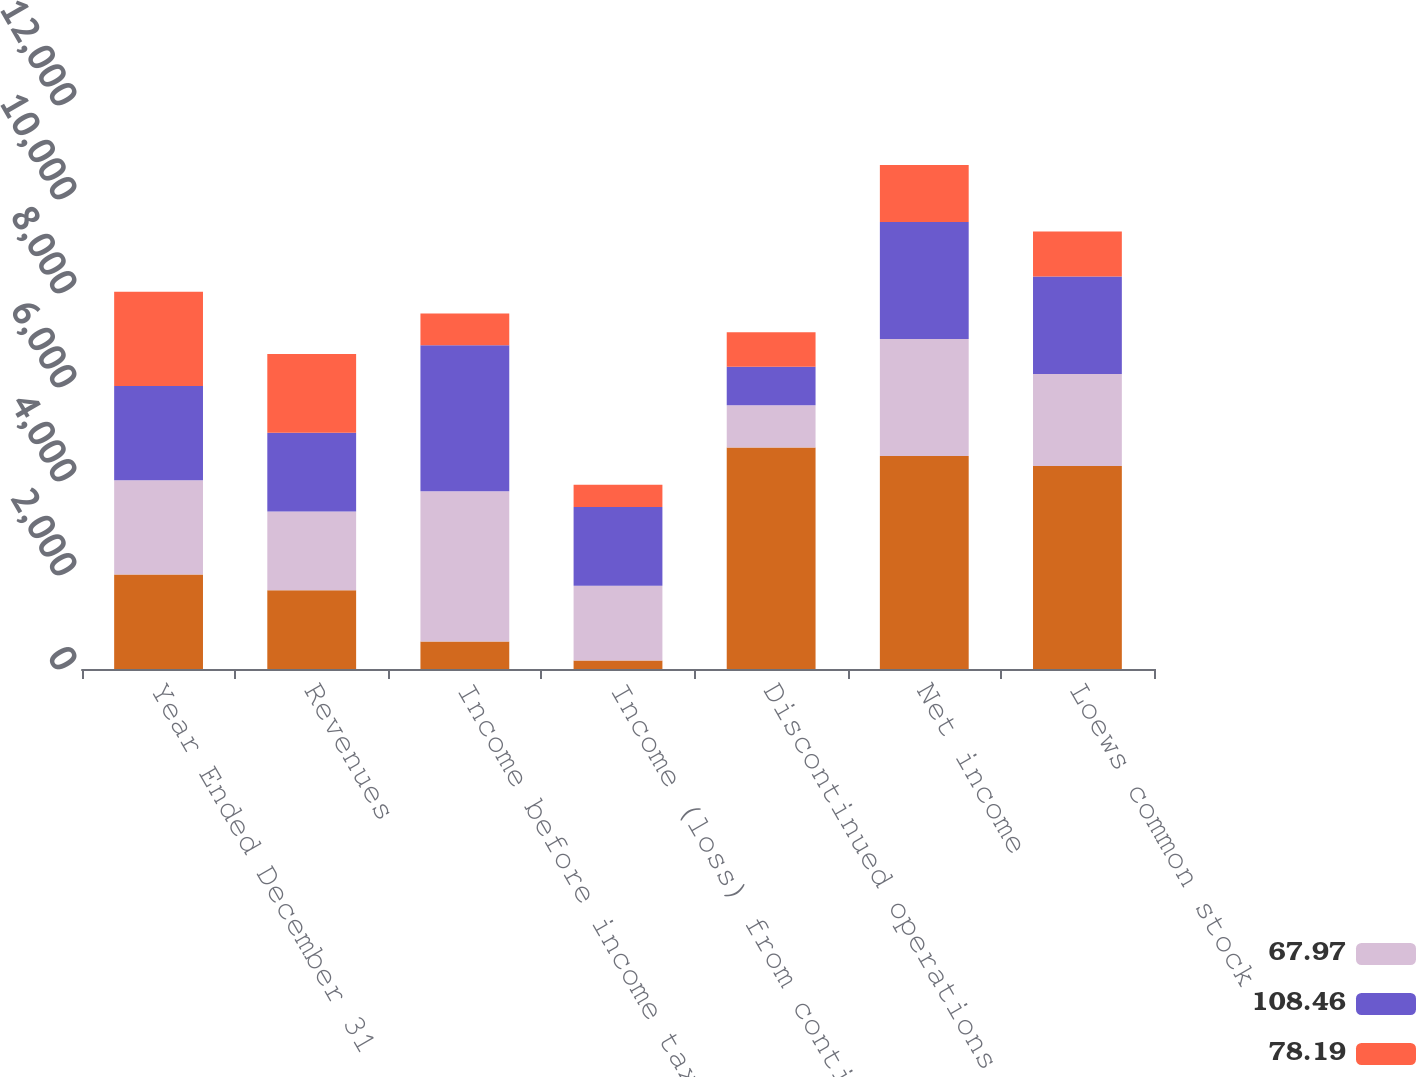Convert chart. <chart><loc_0><loc_0><loc_500><loc_500><stacked_bar_chart><ecel><fcel>Year Ended December 31<fcel>Revenues<fcel>Income before income tax and<fcel>Income (loss) from continuing<fcel>Discontinued operations net<fcel>Net income<fcel>Loews common stock<nl><fcel>nan<fcel>2008<fcel>1676<fcel>587<fcel>182<fcel>4712<fcel>4530<fcel>4319<nl><fcel>67.97<fcel>2007<fcel>1676<fcel>3195<fcel>1587<fcel>902<fcel>2489<fcel>1956<nl><fcel>108.46<fcel>2006<fcel>1676<fcel>3104<fcel>1676<fcel>815<fcel>2491<fcel>2075<nl><fcel>78.19<fcel>2005<fcel>1676<fcel>676<fcel>475<fcel>737<fcel>1212<fcel>961<nl></chart> 